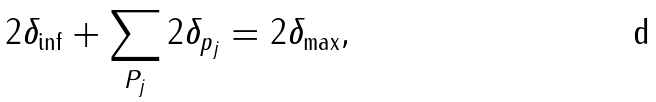<formula> <loc_0><loc_0><loc_500><loc_500>2 \delta _ { \inf } + \sum _ { P _ { j } } 2 \delta _ { p _ { j } } = 2 \delta _ { \max } ,</formula> 